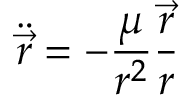<formula> <loc_0><loc_0><loc_500><loc_500>{ \ddot { \vec { r } } } = - { \frac { \mu } { r ^ { 2 } } } { \frac { \vec { r } } { r } }</formula> 